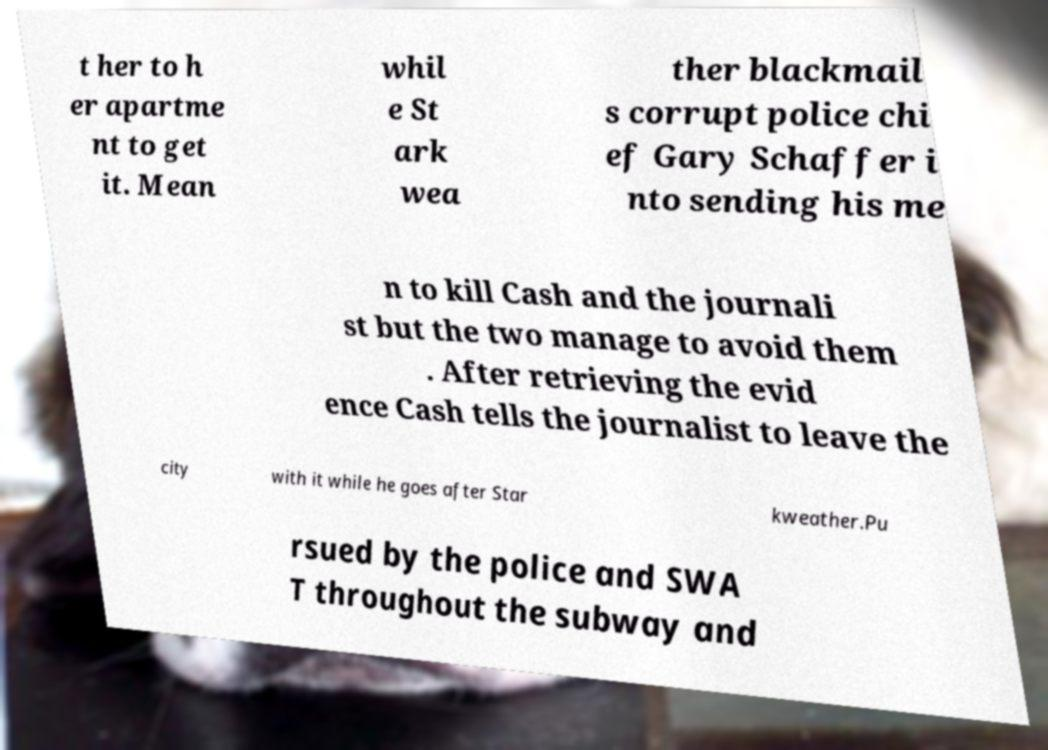There's text embedded in this image that I need extracted. Can you transcribe it verbatim? t her to h er apartme nt to get it. Mean whil e St ark wea ther blackmail s corrupt police chi ef Gary Schaffer i nto sending his me n to kill Cash and the journali st but the two manage to avoid them . After retrieving the evid ence Cash tells the journalist to leave the city with it while he goes after Star kweather.Pu rsued by the police and SWA T throughout the subway and 